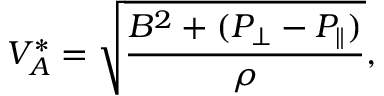Convert formula to latex. <formula><loc_0><loc_0><loc_500><loc_500>V _ { A } ^ { * } = \sqrt { \frac { B ^ { 2 } + ( P _ { \perp } - P _ { \| } ) } { \rho } } ,</formula> 